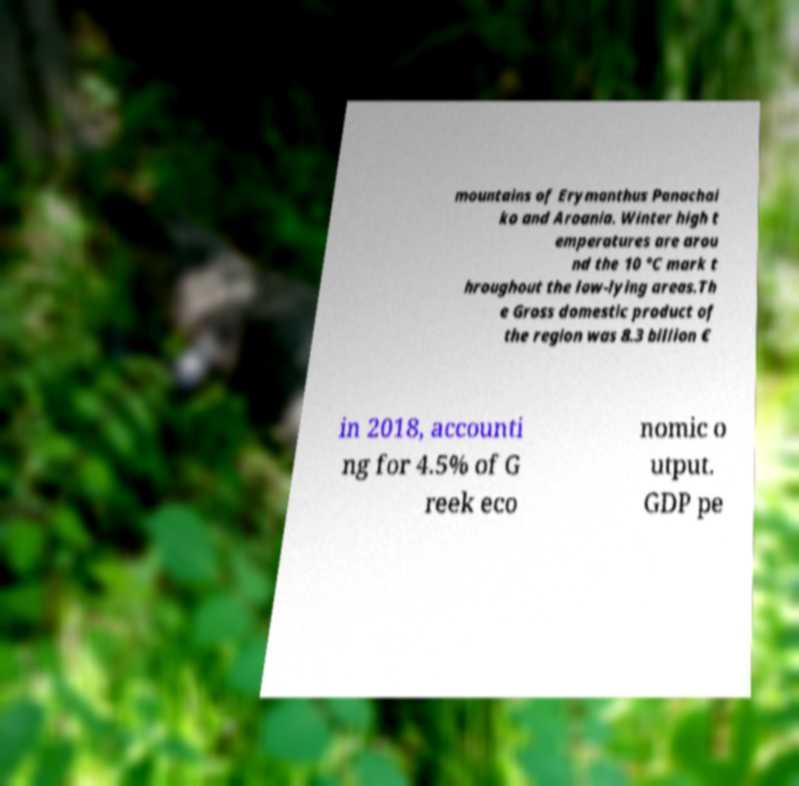Please identify and transcribe the text found in this image. mountains of Erymanthus Panachai ko and Aroania. Winter high t emperatures are arou nd the 10 °C mark t hroughout the low-lying areas.Th e Gross domestic product of the region was 8.3 billion € in 2018, accounti ng for 4.5% of G reek eco nomic o utput. GDP pe 